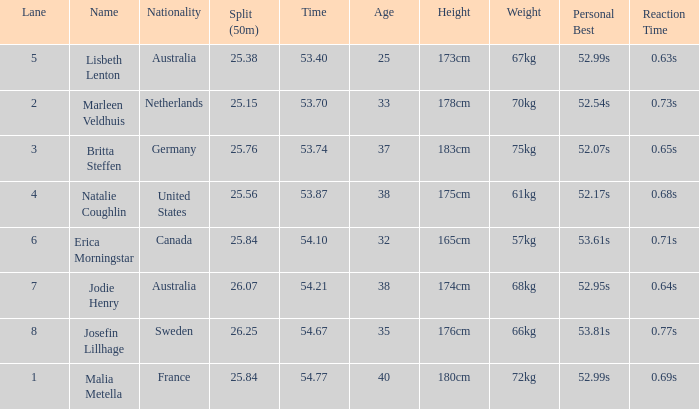What is the total sum of 50m splits for josefin lillhage in lanes above 8? None. 